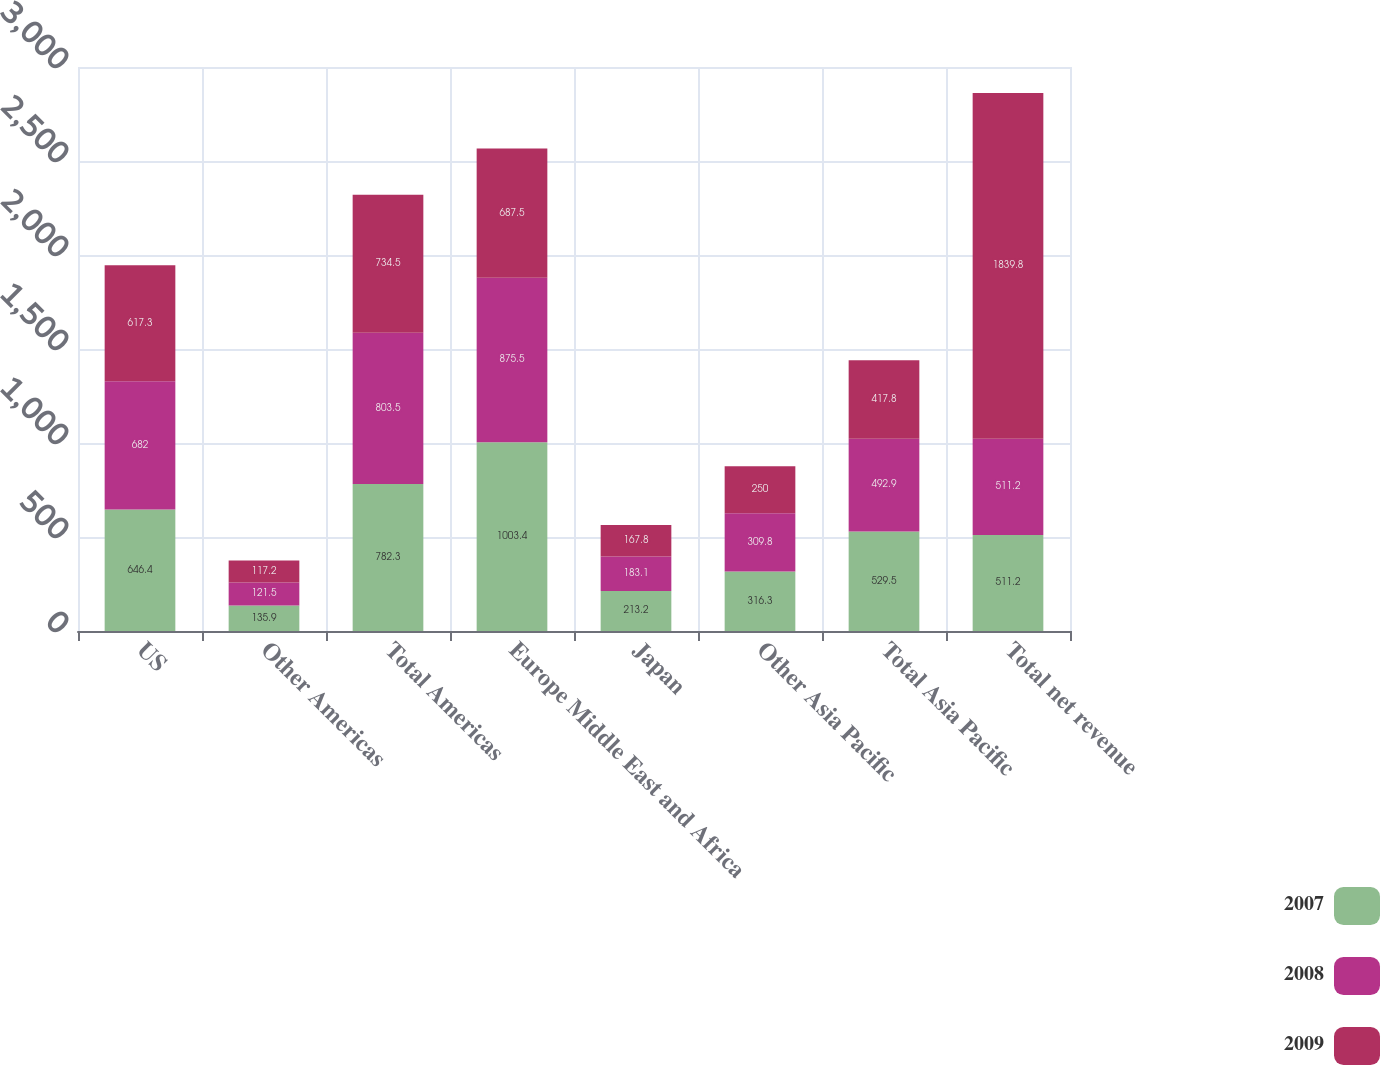Convert chart to OTSL. <chart><loc_0><loc_0><loc_500><loc_500><stacked_bar_chart><ecel><fcel>US<fcel>Other Americas<fcel>Total Americas<fcel>Europe Middle East and Africa<fcel>Japan<fcel>Other Asia Pacific<fcel>Total Asia Pacific<fcel>Total net revenue<nl><fcel>2007<fcel>646.4<fcel>135.9<fcel>782.3<fcel>1003.4<fcel>213.2<fcel>316.3<fcel>529.5<fcel>511.2<nl><fcel>2008<fcel>682<fcel>121.5<fcel>803.5<fcel>875.5<fcel>183.1<fcel>309.8<fcel>492.9<fcel>511.2<nl><fcel>2009<fcel>617.3<fcel>117.2<fcel>734.5<fcel>687.5<fcel>167.8<fcel>250<fcel>417.8<fcel>1839.8<nl></chart> 